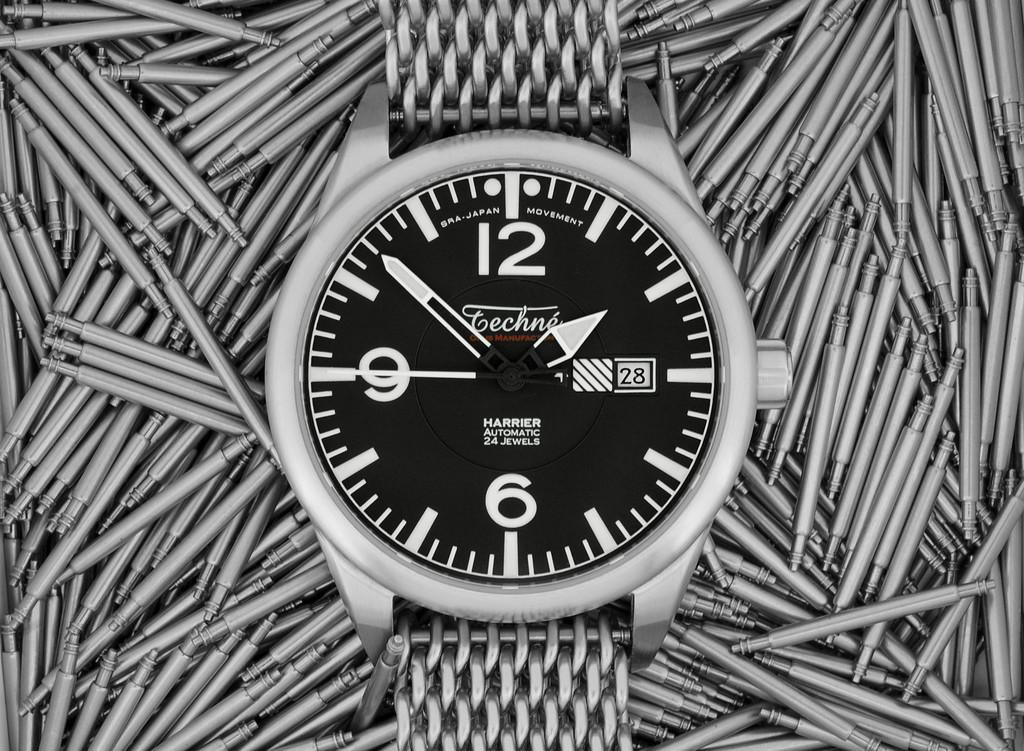<image>
Summarize the visual content of the image. Manufacturer Techne displays a wristwatch reading the date of the 28th at the time of 1:52. 